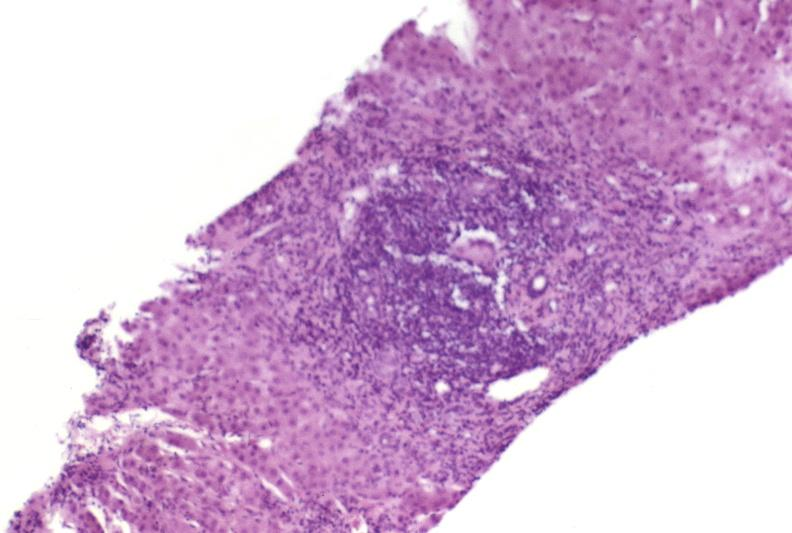s liver present?
Answer the question using a single word or phrase. Yes 